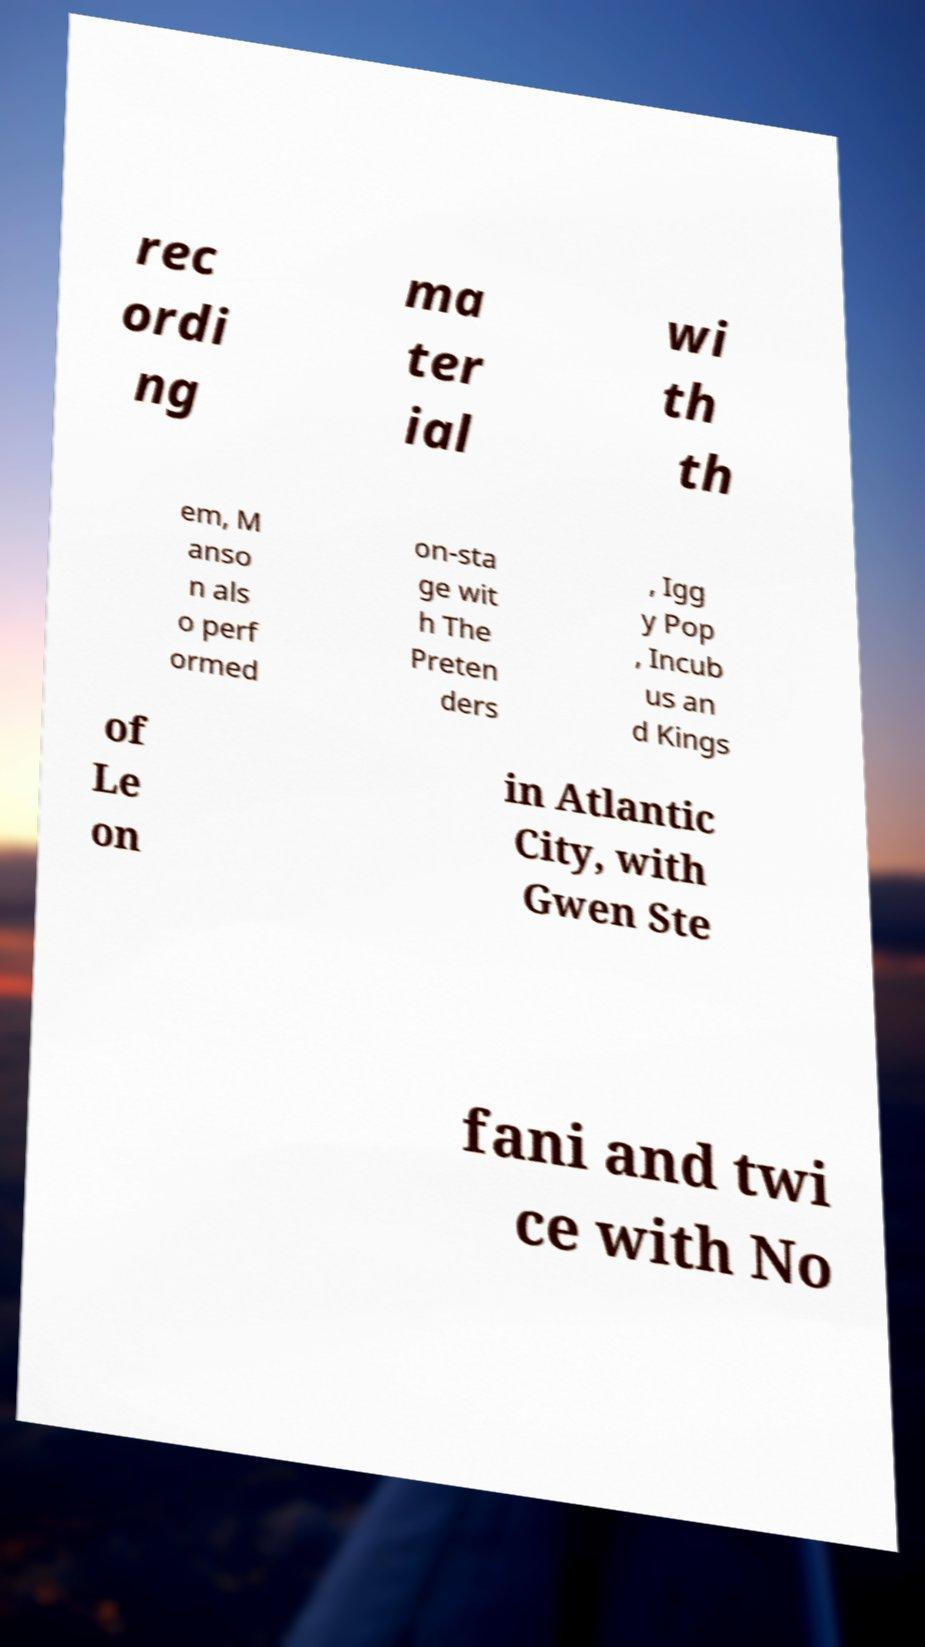Could you assist in decoding the text presented in this image and type it out clearly? rec ordi ng ma ter ial wi th th em, M anso n als o perf ormed on-sta ge wit h The Preten ders , Igg y Pop , Incub us an d Kings of Le on in Atlantic City, with Gwen Ste fani and twi ce with No 